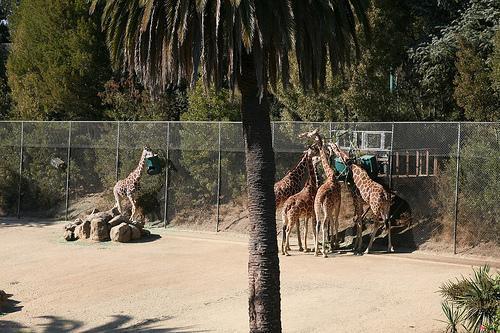How many giraffes in the fence?
Give a very brief answer. 5. 